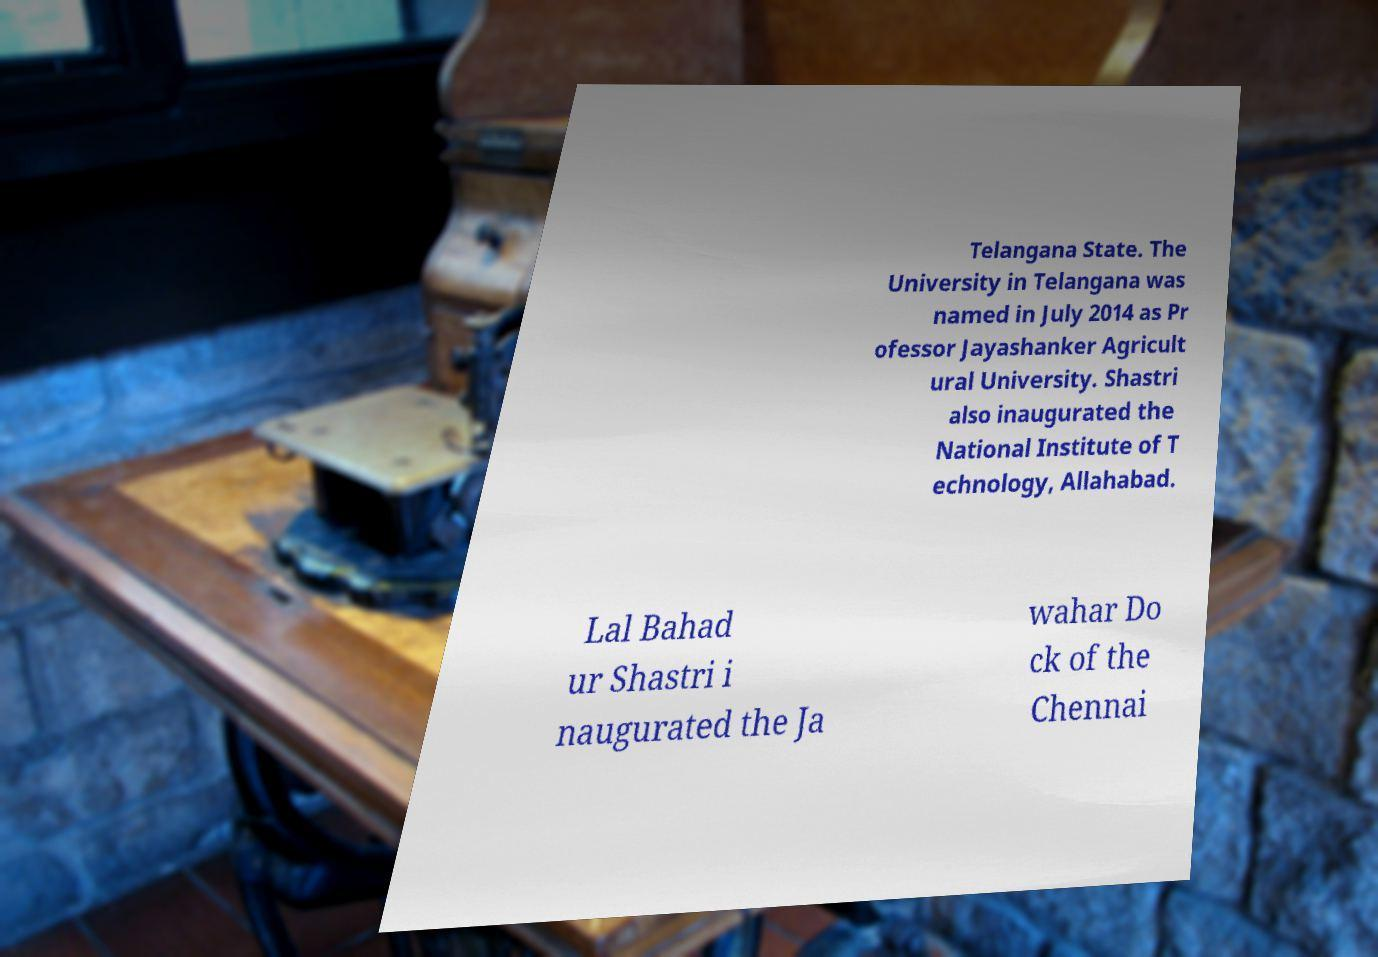Please read and relay the text visible in this image. What does it say? Telangana State. The University in Telangana was named in July 2014 as Pr ofessor Jayashanker Agricult ural University. Shastri also inaugurated the National Institute of T echnology, Allahabad. Lal Bahad ur Shastri i naugurated the Ja wahar Do ck of the Chennai 